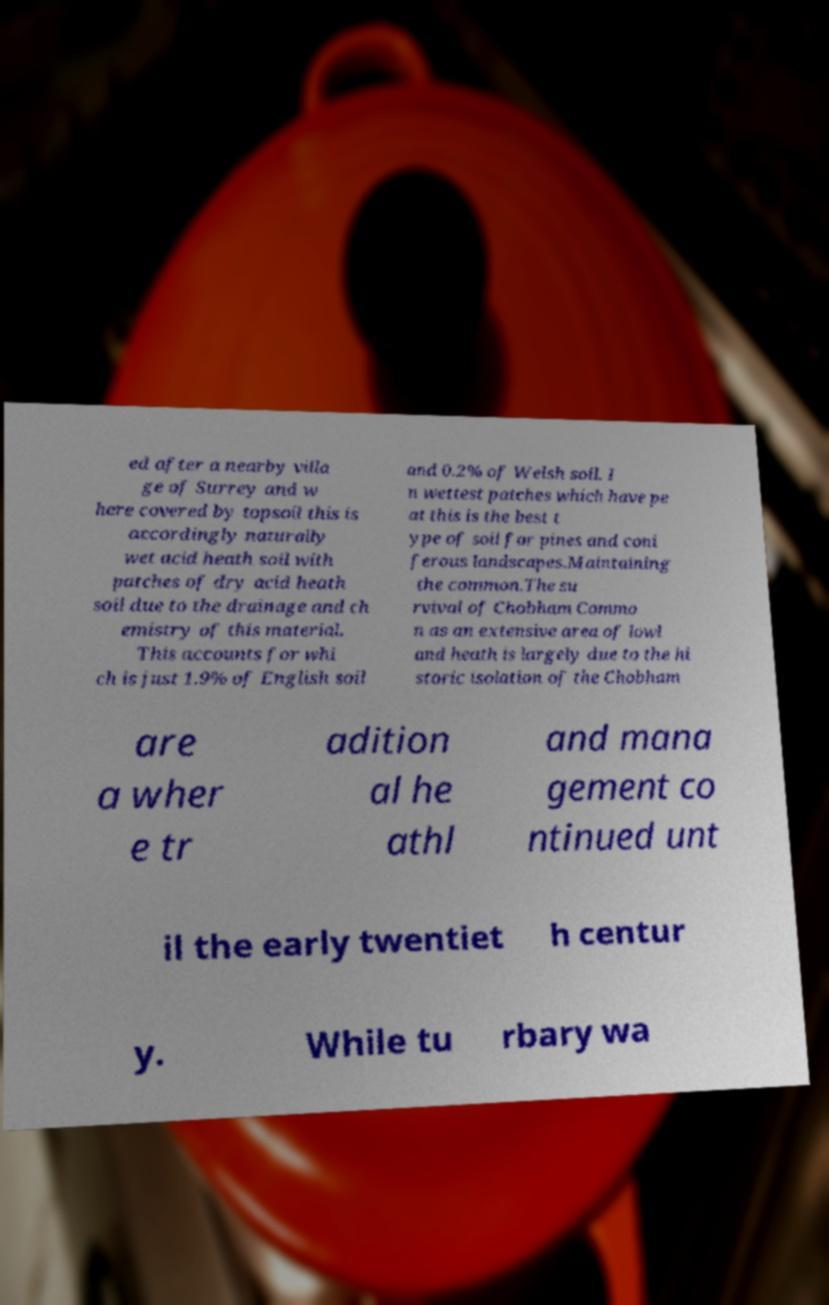Could you assist in decoding the text presented in this image and type it out clearly? ed after a nearby villa ge of Surrey and w here covered by topsoil this is accordingly naturally wet acid heath soil with patches of dry acid heath soil due to the drainage and ch emistry of this material. This accounts for whi ch is just 1.9% of English soil and 0.2% of Welsh soil. I n wettest patches which have pe at this is the best t ype of soil for pines and coni ferous landscapes.Maintaining the common.The su rvival of Chobham Commo n as an extensive area of lowl and heath is largely due to the hi storic isolation of the Chobham are a wher e tr adition al he athl and mana gement co ntinued unt il the early twentiet h centur y. While tu rbary wa 